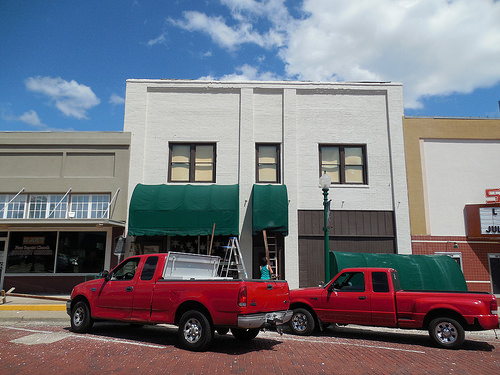<image>
Is there a building in front of the truck? No. The building is not in front of the truck. The spatial positioning shows a different relationship between these objects. 